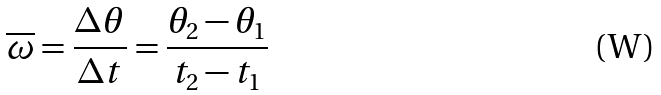Convert formula to latex. <formula><loc_0><loc_0><loc_500><loc_500>\overline { \omega } = \frac { \Delta \theta } { \Delta t } = \frac { \theta _ { 2 } - \theta _ { 1 } } { t _ { 2 } - t _ { 1 } }</formula> 